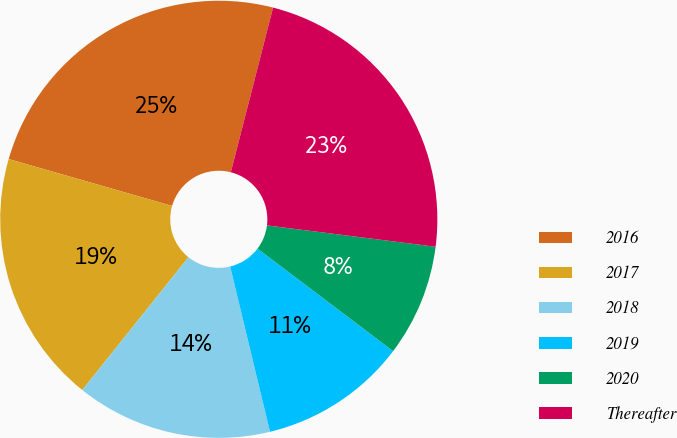Convert chart to OTSL. <chart><loc_0><loc_0><loc_500><loc_500><pie_chart><fcel>2016<fcel>2017<fcel>2018<fcel>2019<fcel>2020<fcel>Thereafter<nl><fcel>24.55%<fcel>18.71%<fcel>14.5%<fcel>10.93%<fcel>8.3%<fcel>23.01%<nl></chart> 